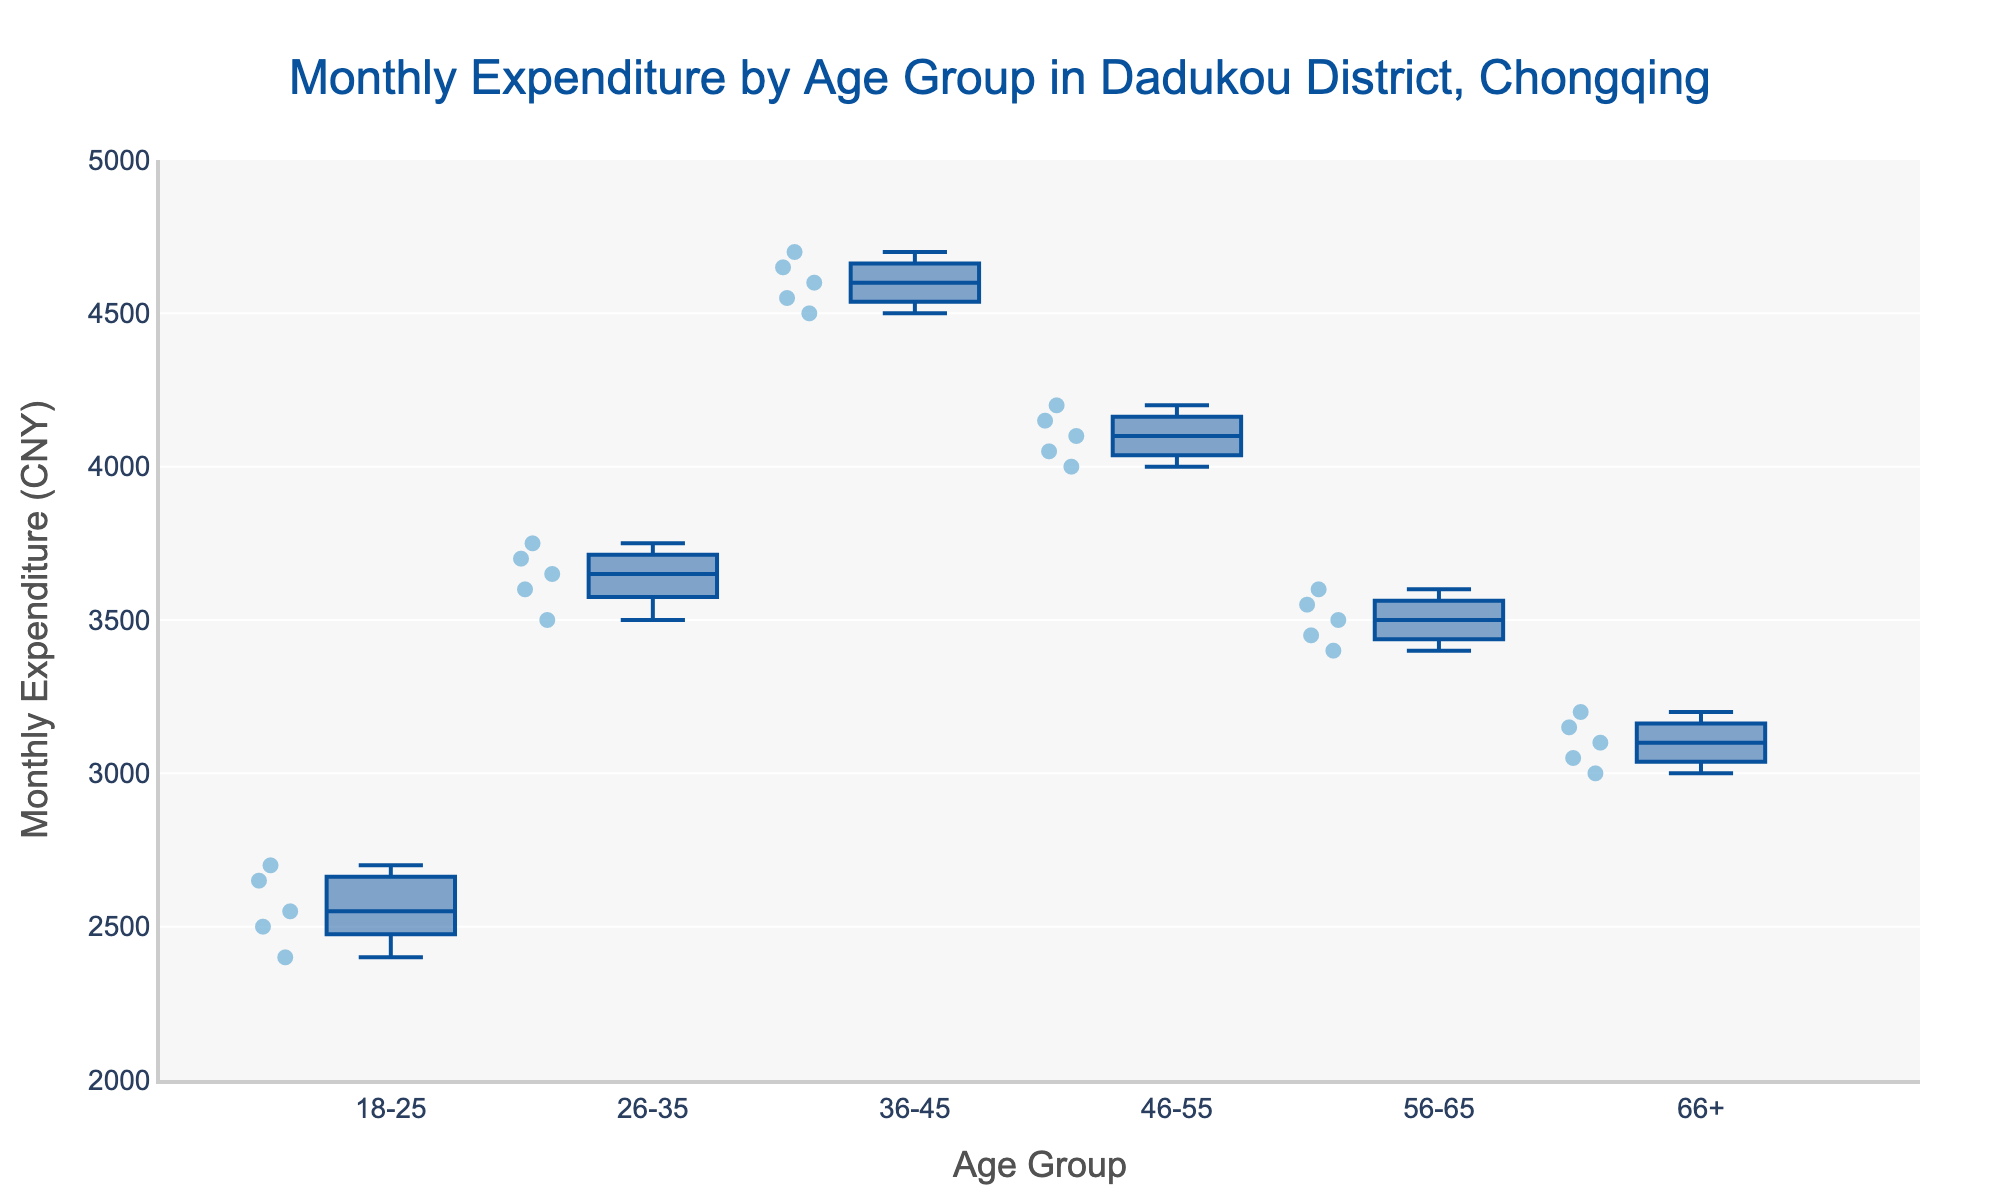What is the title of the box plot? The title is the text displayed at the top and is usually the most prominent text in the figure. It helps understand what the chart represents.
Answer: Monthly Expenditure by Age Group in Dadukou District, Chongqing Which age group has the highest median monthly expenditure? To find the median expenditure, look at the line inside the box for each age group. The highest median is the longest vertical line.
Answer: 36-45 What is the median monthly expenditure for the 66+ age group? The median value is indicated by the line inside the box plot for the 66+ age group.
Answer: 3100 CNY Which age group shows the widest range in monthly expenditure? The range can be determined by the length of the box from the bottom to the top. The group with the longest box has the widest range.
Answer: 36-45 Which age group has the smallest IQR (Interquartile Range) in monthly expenditures? The IQR is represented by the length of the box portion of each plot. The smallest IQR will correspond to the shortest box.
Answer: 26-35 How many data points are there for the 26-35 age group? The number of data points can be determined by counting the individual marks (points) within and outside the box plot for the 26-35 age group.
Answer: 5 Which age group has the lowest overall monthly expenditure? This can be identified by finding the lowest point among all the points in the box plots.
Answer: 18-25 Compare the median expenditures of the 18-25 and 56-65 age groups. Which one is higher? Compare the median lines (lines inside the boxes) of both age groups. The higher line indicates the higher median expenditure.
Answer: 56-65 What is the interquartile range (IQR) for the 36-45 age group? The IQR is calculated as the difference between the upper quartile (top of the box) and the lower quartile (bottom of the box) for the 36-45 age group.
Answer: 150 CNY Identify the age group with the least variation in monthly expenditure. Variation is indicated by the length of the box and whiskers. The age group with the shorter box and whiskers combined has the least variation.
Answer: 26-35 